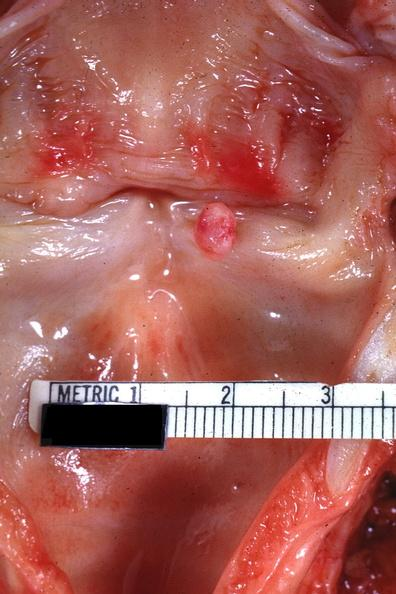where is this?
Answer the question using a single word or phrase. Oral 